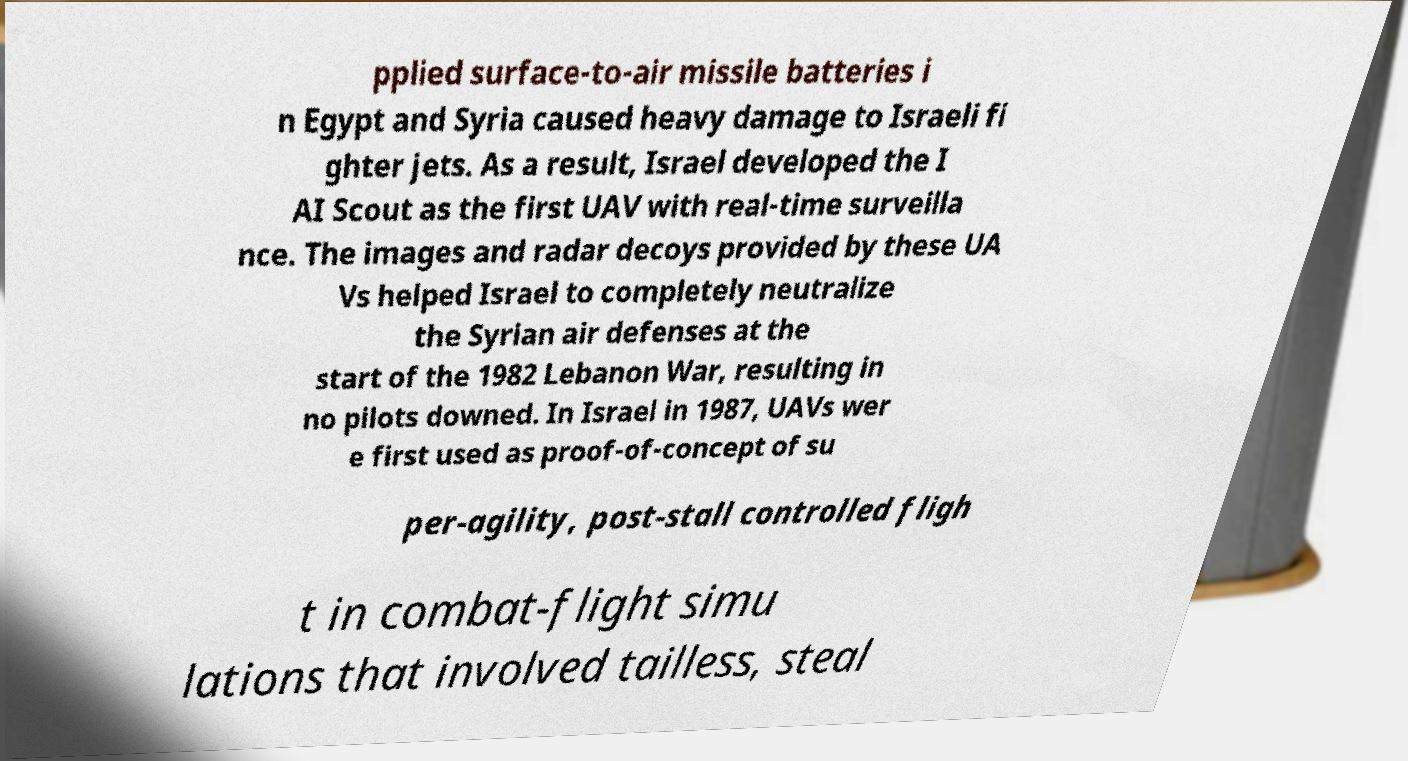Can you read and provide the text displayed in the image?This photo seems to have some interesting text. Can you extract and type it out for me? pplied surface-to-air missile batteries i n Egypt and Syria caused heavy damage to Israeli fi ghter jets. As a result, Israel developed the I AI Scout as the first UAV with real-time surveilla nce. The images and radar decoys provided by these UA Vs helped Israel to completely neutralize the Syrian air defenses at the start of the 1982 Lebanon War, resulting in no pilots downed. In Israel in 1987, UAVs wer e first used as proof-of-concept of su per-agility, post-stall controlled fligh t in combat-flight simu lations that involved tailless, steal 